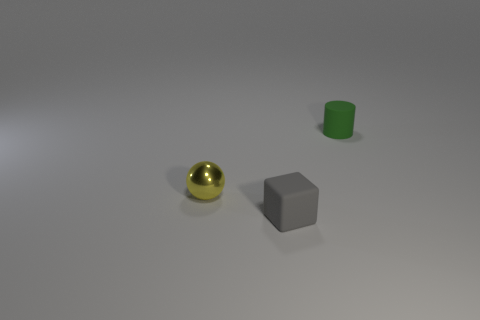What is the color of the cylinder that is the same size as the yellow shiny object?
Provide a succinct answer. Green. Is the cylinder made of the same material as the tiny yellow ball?
Provide a short and direct response. No. There is a tiny object on the right side of the tiny rubber object to the left of the tiny matte cylinder; what is its material?
Offer a very short reply. Rubber. Are there more small yellow objects that are in front of the green rubber thing than big blue rubber cylinders?
Provide a short and direct response. Yes. How many other things are the same size as the green matte object?
Keep it short and to the point. 2. What is the color of the rubber thing to the left of the small matte thing to the right of the tiny object that is in front of the small metallic thing?
Your response must be concise. Gray. There is a matte thing that is left of the tiny rubber thing that is to the right of the cube; how many things are to the left of it?
Provide a succinct answer. 1. Is there any other thing that is the same color as the small matte cube?
Your answer should be very brief. No. There is a tiny object that is on the left side of the block; how many cubes are right of it?
Keep it short and to the point. 1. There is a tiny thing that is to the right of the thing that is in front of the small yellow metal ball; is there a yellow sphere in front of it?
Ensure brevity in your answer.  Yes. 